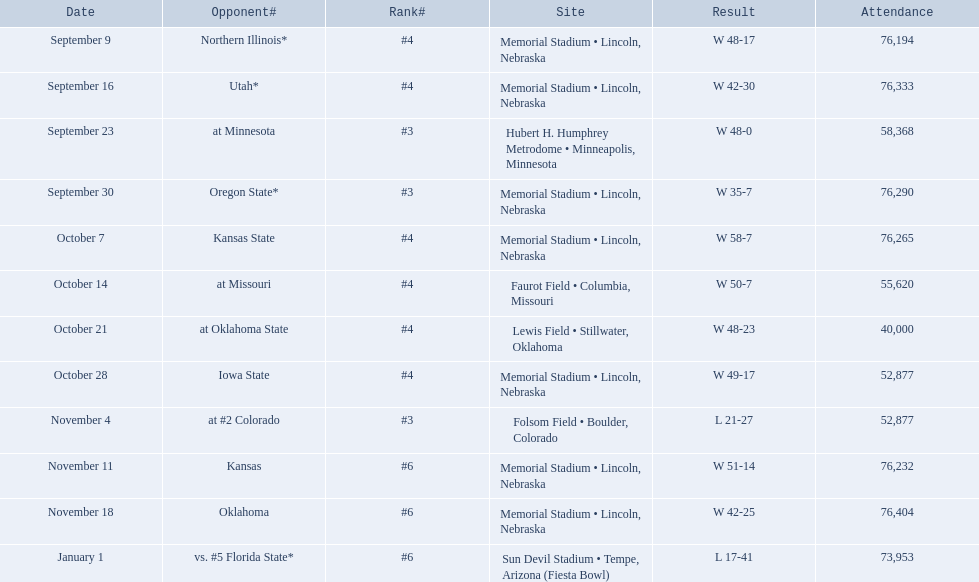Who were all of their opponents? Northern Illinois*, Utah*, at Minnesota, Oregon State*, Kansas State, at Missouri, at Oklahoma State, Iowa State, at #2 Colorado, Kansas, Oklahoma, vs. #5 Florida State*. And what was the attendance of these games? 76,194, 76,333, 58,368, 76,290, 76,265, 55,620, 40,000, 52,877, 52,877, 76,232, 76,404, 73,953. Of those numbers, which is associated with the oregon state game? 76,290. 